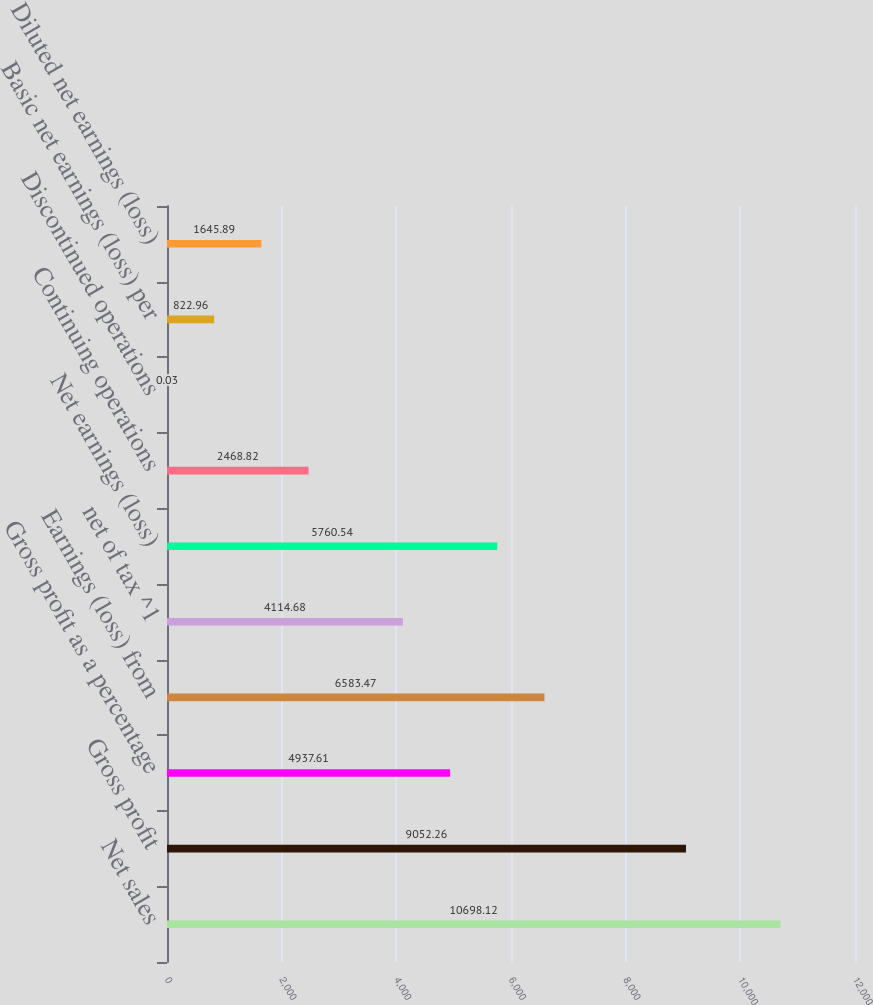Convert chart to OTSL. <chart><loc_0><loc_0><loc_500><loc_500><bar_chart><fcel>Net sales<fcel>Gross profit<fcel>Gross profit as a percentage<fcel>Earnings (loss) from<fcel>net of tax ^1<fcel>Net earnings (loss)<fcel>Continuing operations<fcel>Discontinued operations<fcel>Basic net earnings (loss) per<fcel>Diluted net earnings (loss)<nl><fcel>10698.1<fcel>9052.26<fcel>4937.61<fcel>6583.47<fcel>4114.68<fcel>5760.54<fcel>2468.82<fcel>0.03<fcel>822.96<fcel>1645.89<nl></chart> 